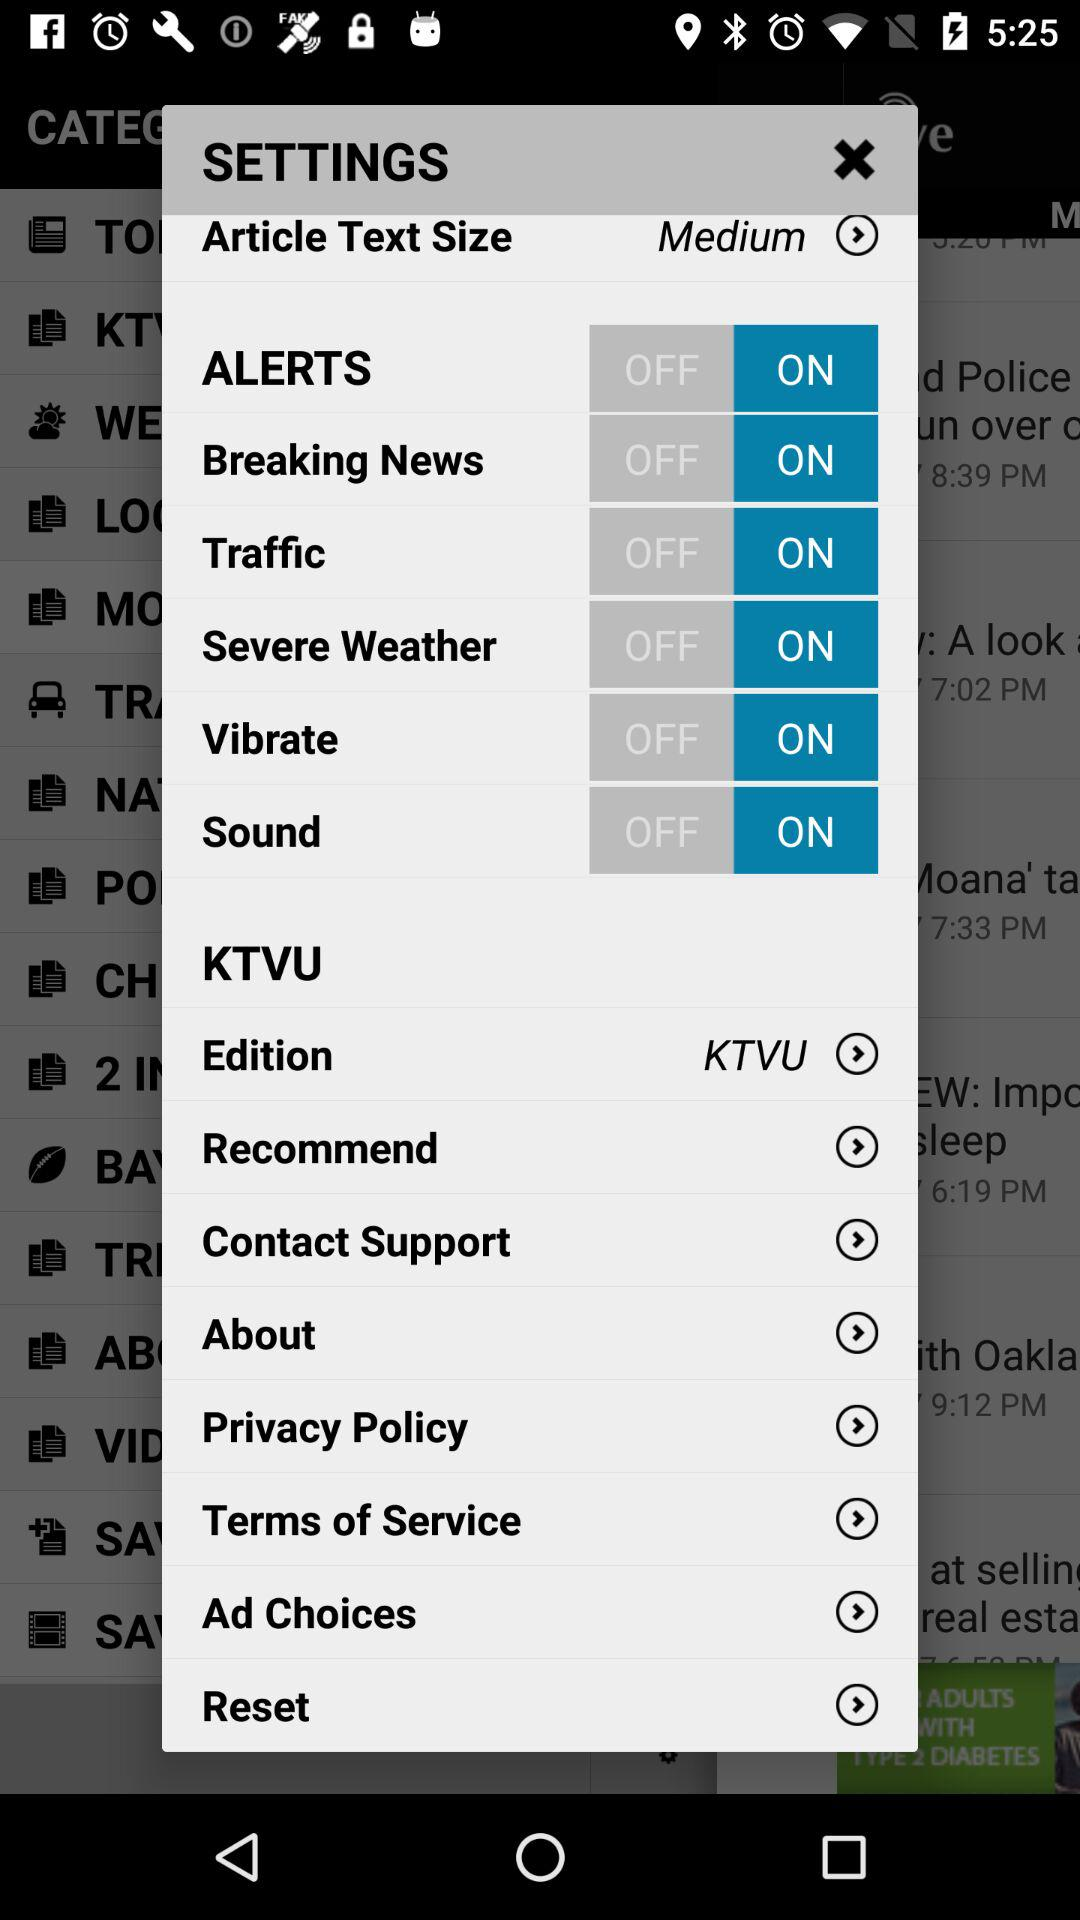What is the status of the "ALERTS"? The status is "on". 